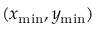<formula> <loc_0><loc_0><loc_500><loc_500>( x _ { \min } , y _ { \min } )</formula> 